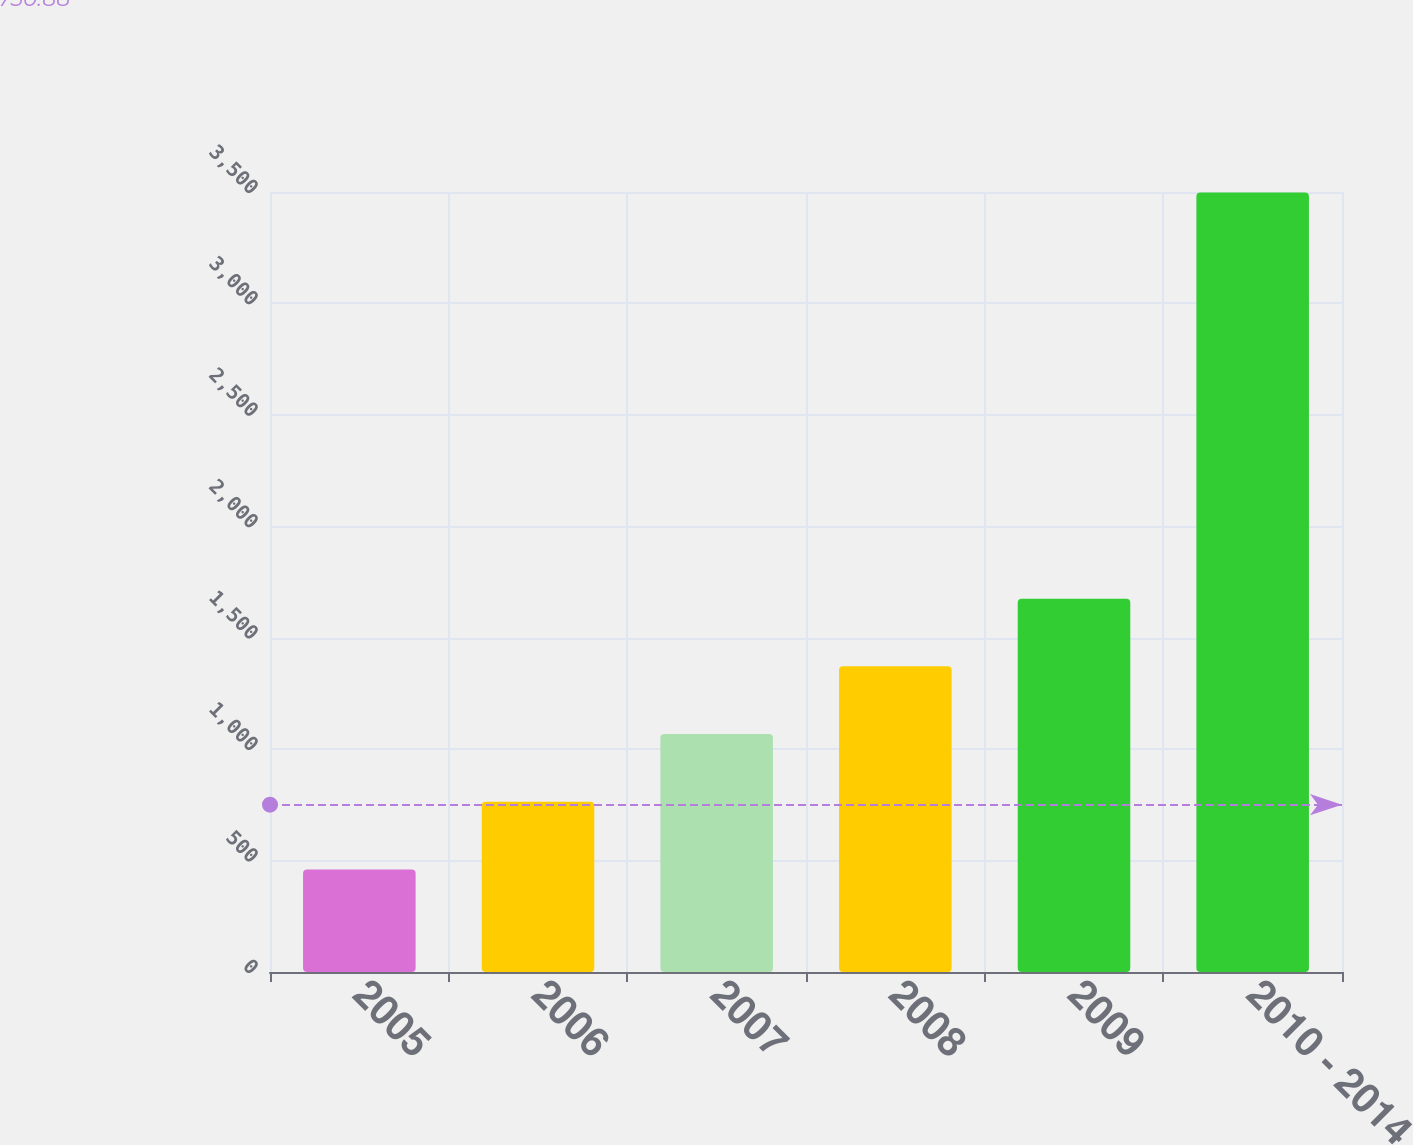<chart> <loc_0><loc_0><loc_500><loc_500><bar_chart><fcel>2005<fcel>2006<fcel>2007<fcel>2008<fcel>2009<fcel>2010 - 2014<nl><fcel>460<fcel>763.8<fcel>1067.6<fcel>1371.4<fcel>1675.2<fcel>3498<nl></chart> 